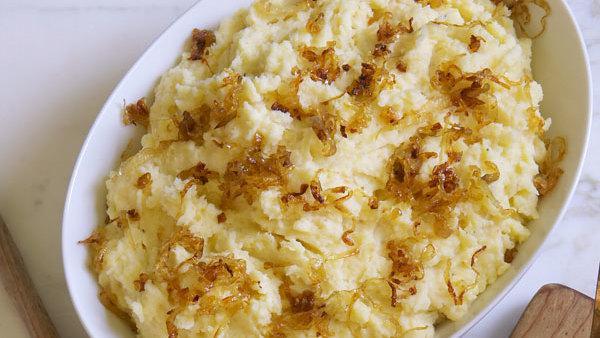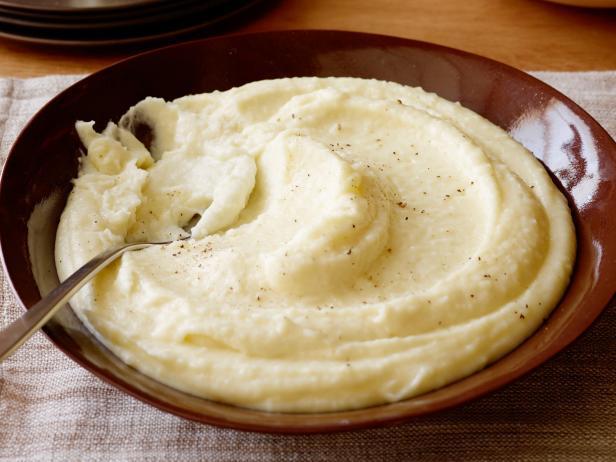The first image is the image on the left, the second image is the image on the right. Examine the images to the left and right. Is the description "A utensil with a handle is in one round bowl of mashed potatoes." accurate? Answer yes or no. Yes. The first image is the image on the left, the second image is the image on the right. For the images displayed, is the sentence "There is a green additive to the bowl on the right, such as parsley." factually correct? Answer yes or no. No. 